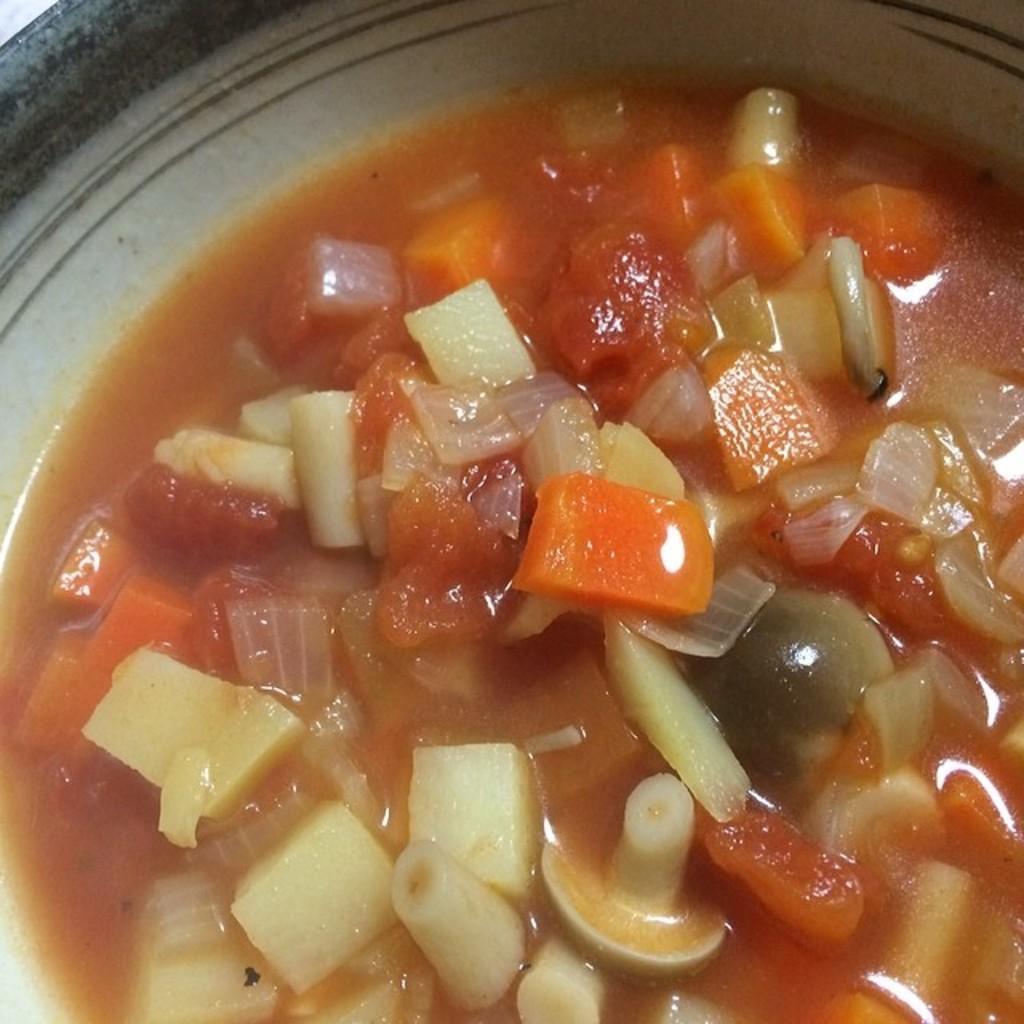How would you summarize this image in a sentence or two? In this picture we can see a bowl,in this bowl we can see a food item such as carrots. 